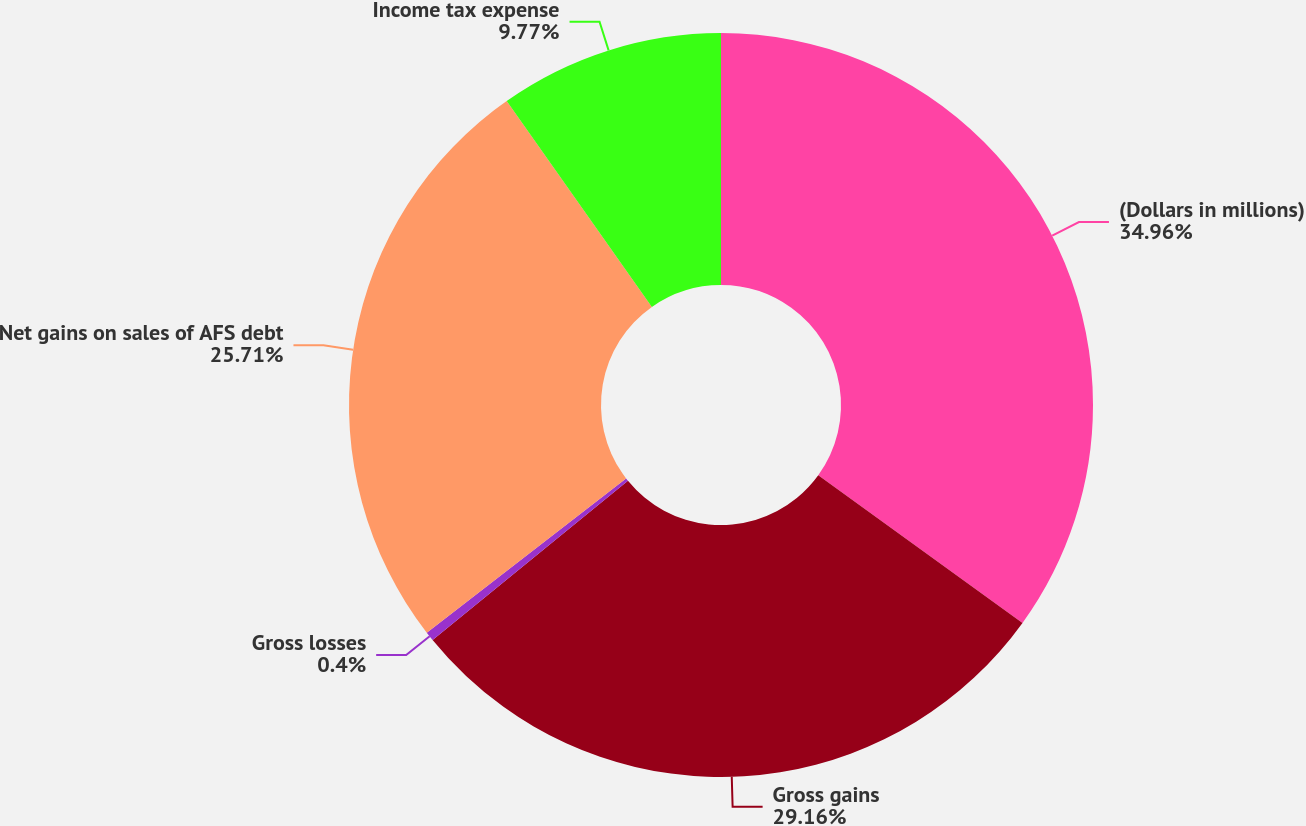Convert chart. <chart><loc_0><loc_0><loc_500><loc_500><pie_chart><fcel>(Dollars in millions)<fcel>Gross gains<fcel>Gross losses<fcel>Net gains on sales of AFS debt<fcel>Income tax expense<nl><fcel>34.96%<fcel>29.16%<fcel>0.4%<fcel>25.71%<fcel>9.77%<nl></chart> 